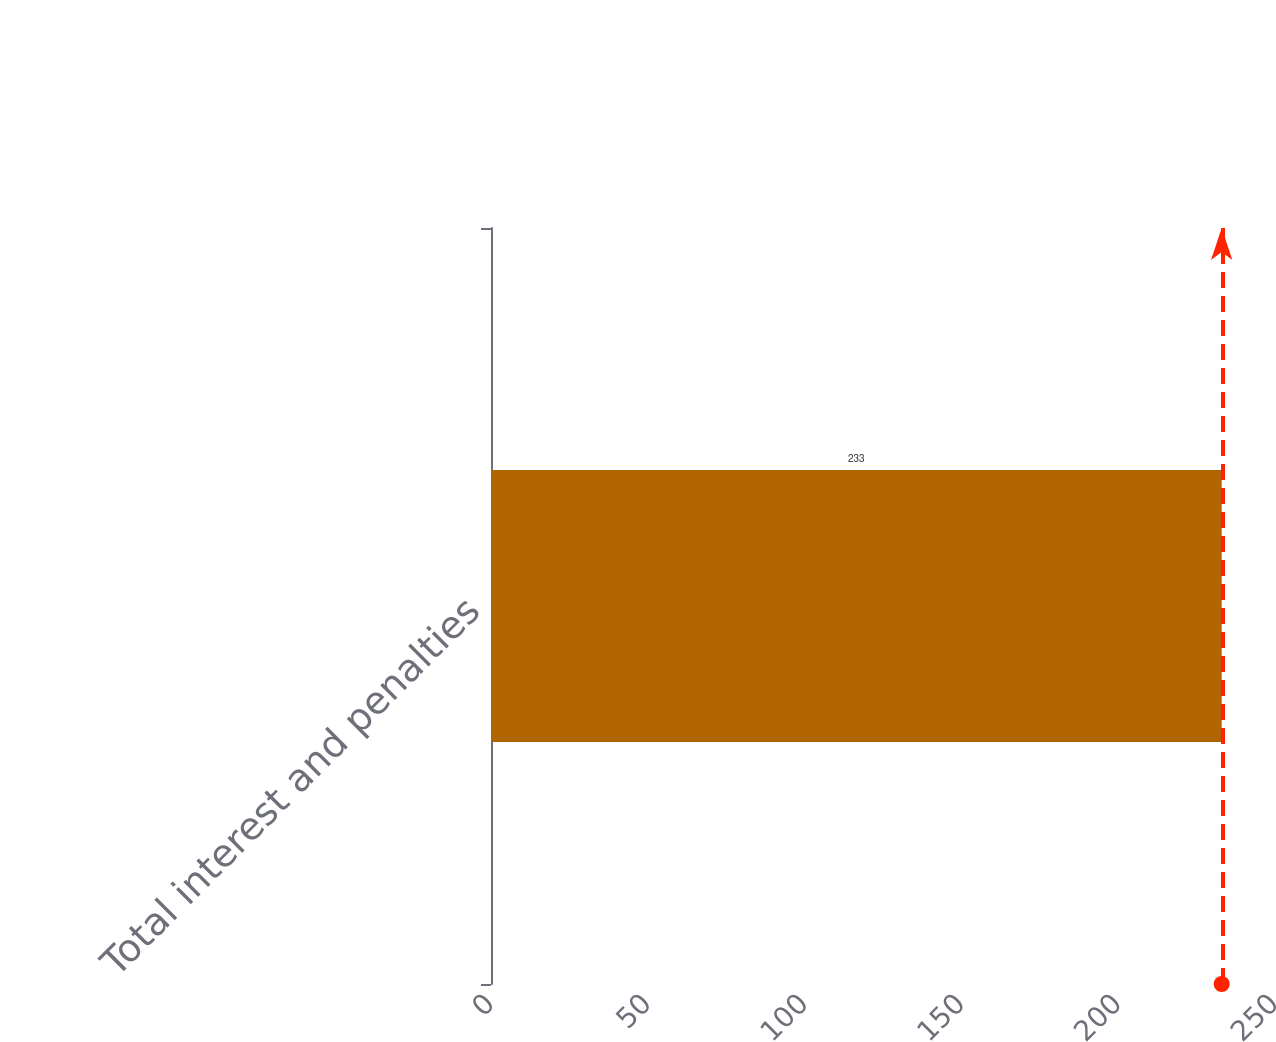Convert chart. <chart><loc_0><loc_0><loc_500><loc_500><bar_chart><fcel>Total interest and penalties<nl><fcel>233<nl></chart> 